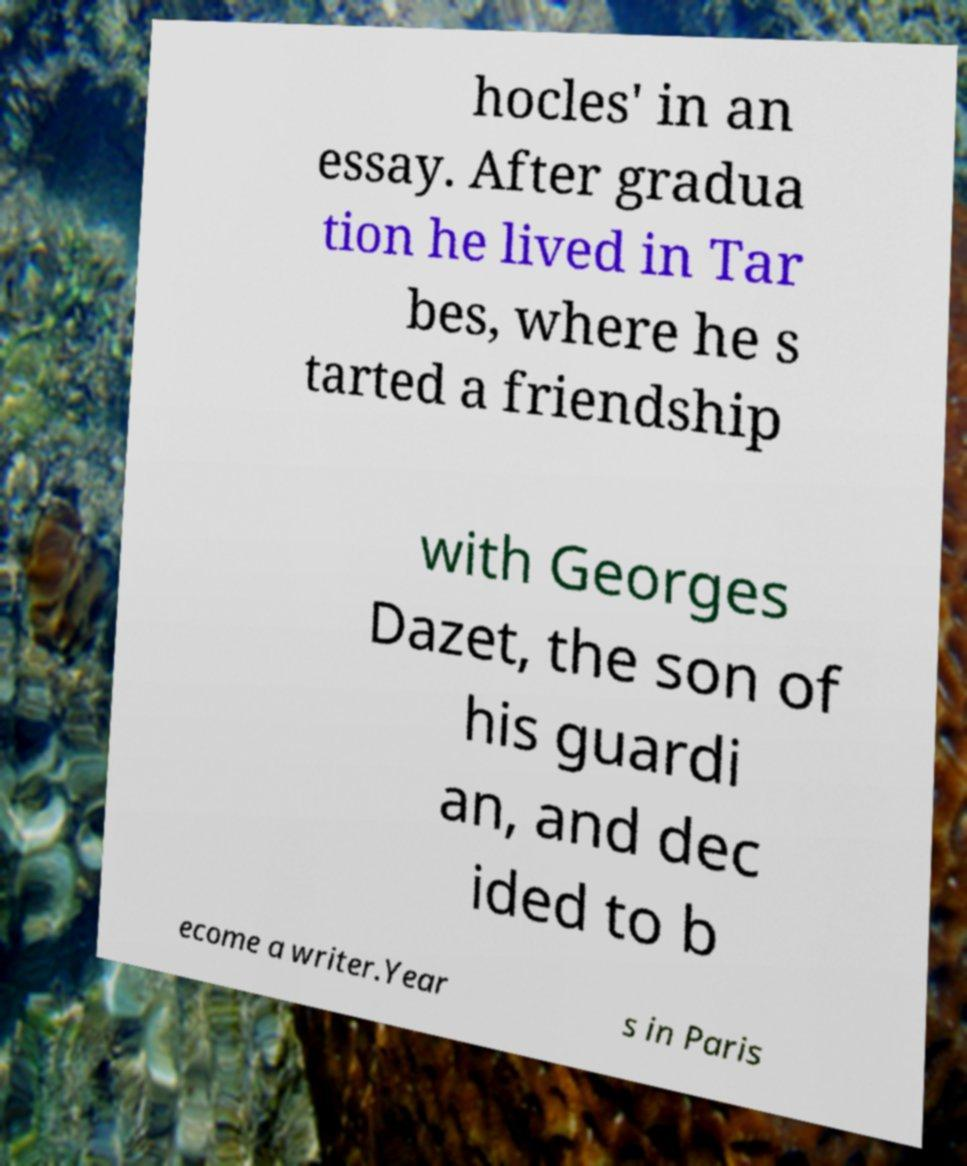Could you extract and type out the text from this image? hocles' in an essay. After gradua tion he lived in Tar bes, where he s tarted a friendship with Georges Dazet, the son of his guardi an, and dec ided to b ecome a writer.Year s in Paris 